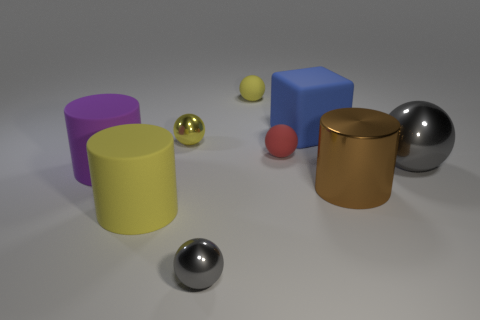What size is the other metal ball that is the same color as the big metal sphere?
Provide a succinct answer. Small. Is there a small metallic thing of the same color as the big shiny sphere?
Provide a succinct answer. Yes. There is a object that is the same color as the large sphere; what shape is it?
Give a very brief answer. Sphere. How many things are metal balls that are in front of the tiny yellow metal ball or red rubber things?
Provide a succinct answer. 3. Are there fewer large purple things than large red rubber cubes?
Your answer should be compact. No. There is a purple object that is made of the same material as the blue cube; what is its shape?
Provide a succinct answer. Cylinder. There is a small yellow shiny sphere; are there any large brown metal objects to the left of it?
Ensure brevity in your answer.  No. Is the number of purple matte objects on the right side of the large yellow cylinder less than the number of small purple shiny cylinders?
Your answer should be very brief. No. What is the red thing made of?
Keep it short and to the point. Rubber. What is the color of the big ball?
Your answer should be very brief. Gray. 